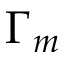Convert formula to latex. <formula><loc_0><loc_0><loc_500><loc_500>\Gamma _ { m }</formula> 